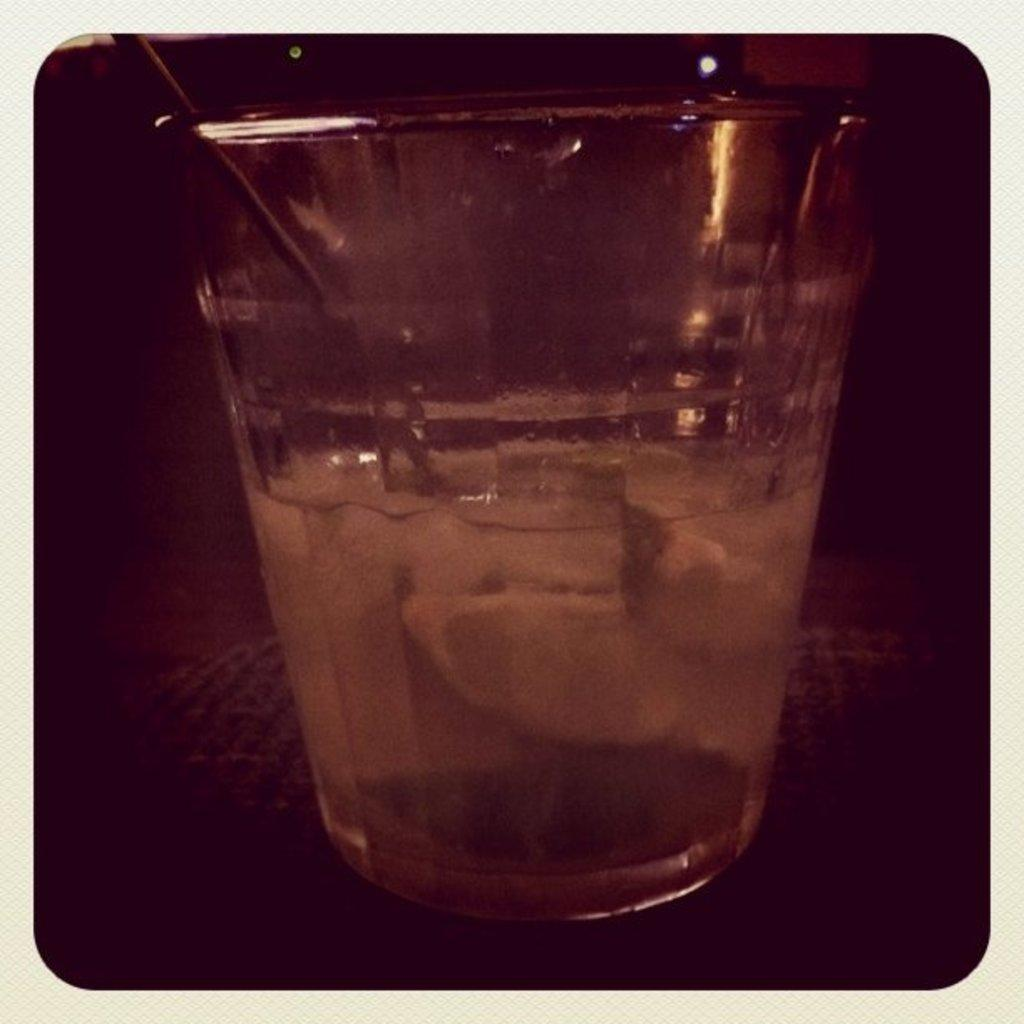What is inside the glass that is visible in the image? There is a stick and liquid in the glass. Can you describe the object in the image? Unfortunately, the provided facts do not give enough information to describe the object in the image. What is the color of the background in the image? The background of the image is dark. What type of porter is serving drinks at the meeting in the image? There is no meeting or porter present in the image. How many cans of soda are visible in the image? There is no mention of cans of soda in the provided facts, so we cannot determine if any are visible in the image. 